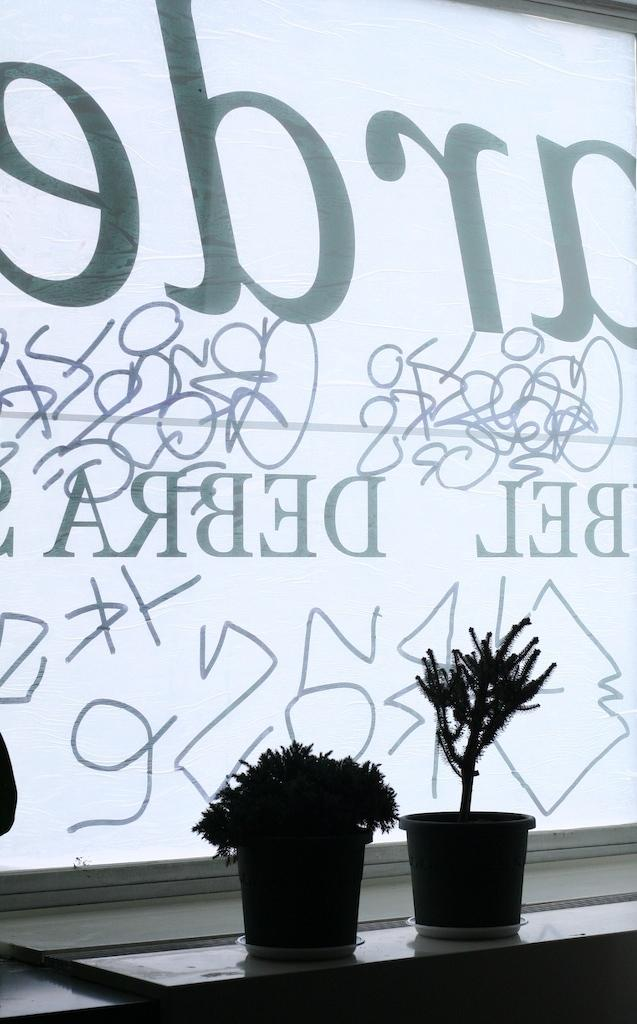What type of objects are present in the image that contain plants? There are flower pots in the image that contain plants. What else can be seen in the image besides the flower pots? There is a board with text in the image. Can you describe the board in the image? Yes, there is a board in the image with text on it. Is there any furniture visible in the image? There might be a table at the bottom of the image. What route do the fangs of the snake take in the image? There are no snakes or fangs present in the image. Is there a playground visible in the image? No, there is no playground visible in the image. 